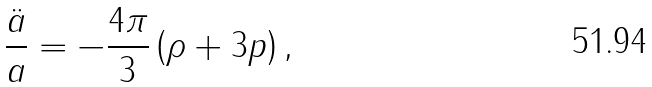Convert formula to latex. <formula><loc_0><loc_0><loc_500><loc_500>\frac { \ddot { a } } { a } = - \frac { 4 \pi } { 3 } \left ( \rho + 3 p \right ) ,</formula> 